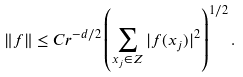Convert formula to latex. <formula><loc_0><loc_0><loc_500><loc_500>\| f \| \leq C r ^ { - d / 2 } \left ( \sum _ { x _ { j } \in Z } | f ( x _ { j } ) | ^ { 2 } \right ) ^ { 1 / 2 } .</formula> 